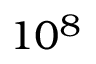Convert formula to latex. <formula><loc_0><loc_0><loc_500><loc_500>1 0 ^ { 8 }</formula> 